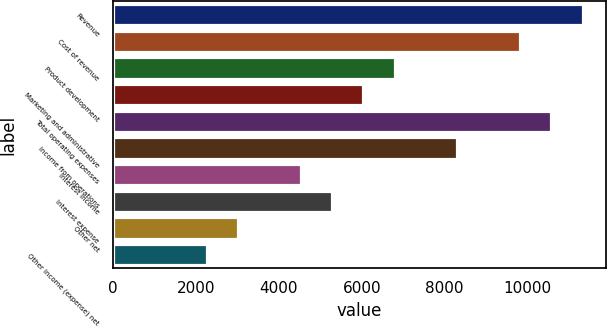Convert chart. <chart><loc_0><loc_0><loc_500><loc_500><bar_chart><fcel>Revenue<fcel>Cost of revenue<fcel>Product development<fcel>Marketing and administrative<fcel>Total operating expenses<fcel>Income from operations<fcel>Interest income<fcel>Interest expense<fcel>Other net<fcel>Other income (expense) net<nl><fcel>11329.3<fcel>9818.77<fcel>6797.69<fcel>6042.42<fcel>10574<fcel>8308.23<fcel>4531.88<fcel>5287.15<fcel>3021.34<fcel>2266.07<nl></chart> 